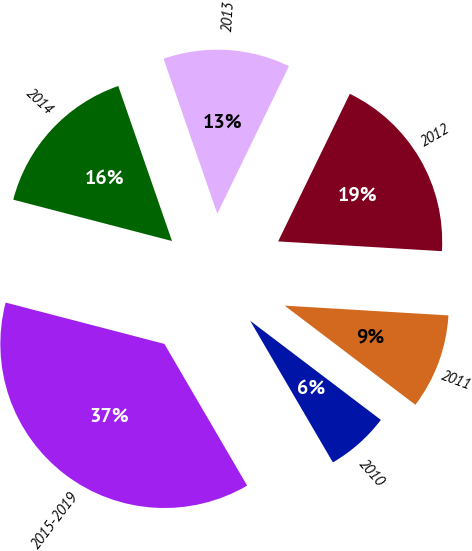Convert chart. <chart><loc_0><loc_0><loc_500><loc_500><pie_chart><fcel>2010<fcel>2011<fcel>2012<fcel>2013<fcel>2014<fcel>2015-2019<nl><fcel>6.26%<fcel>9.38%<fcel>18.75%<fcel>12.51%<fcel>15.63%<fcel>37.47%<nl></chart> 